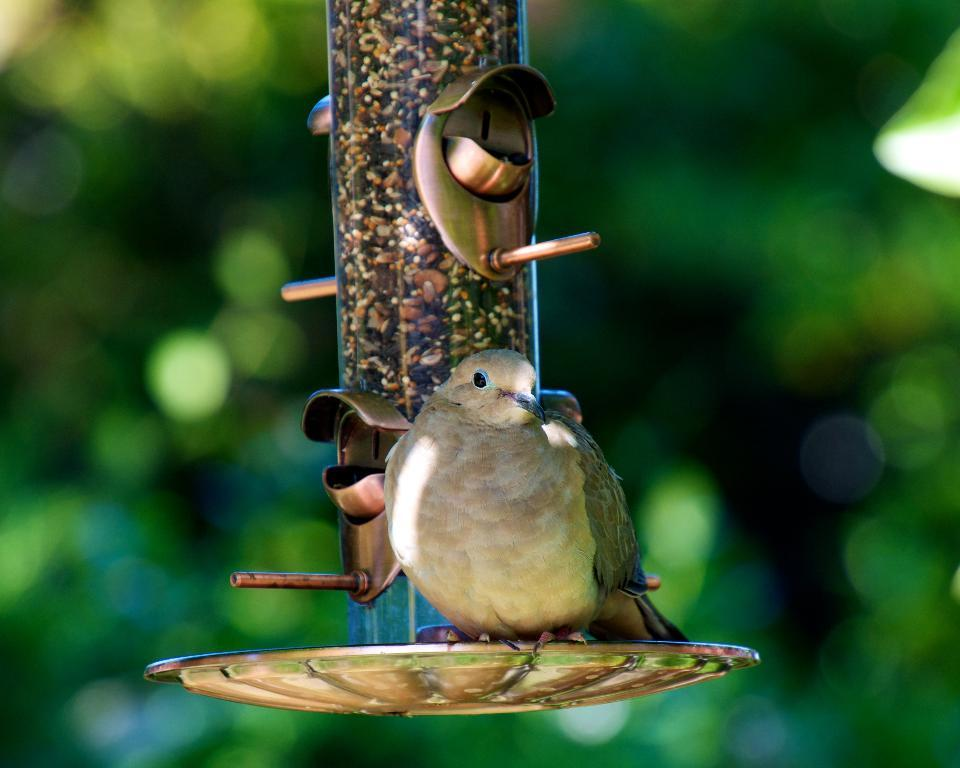What type of animal is in the picture? There is a bird in the picture. Can you describe the bird's appearance? The bird is cream-colored. What is located in the middle of the picture? There is a pole in the middle of the picture. How would you describe the background of the image? The background of the image is blurred and cream-colored. What type of toy can be seen on the sidewalk in the image? There is no toy or sidewalk present in the image. Can you hear the drum being played in the image? There is no drum or indication of sound in the image. 